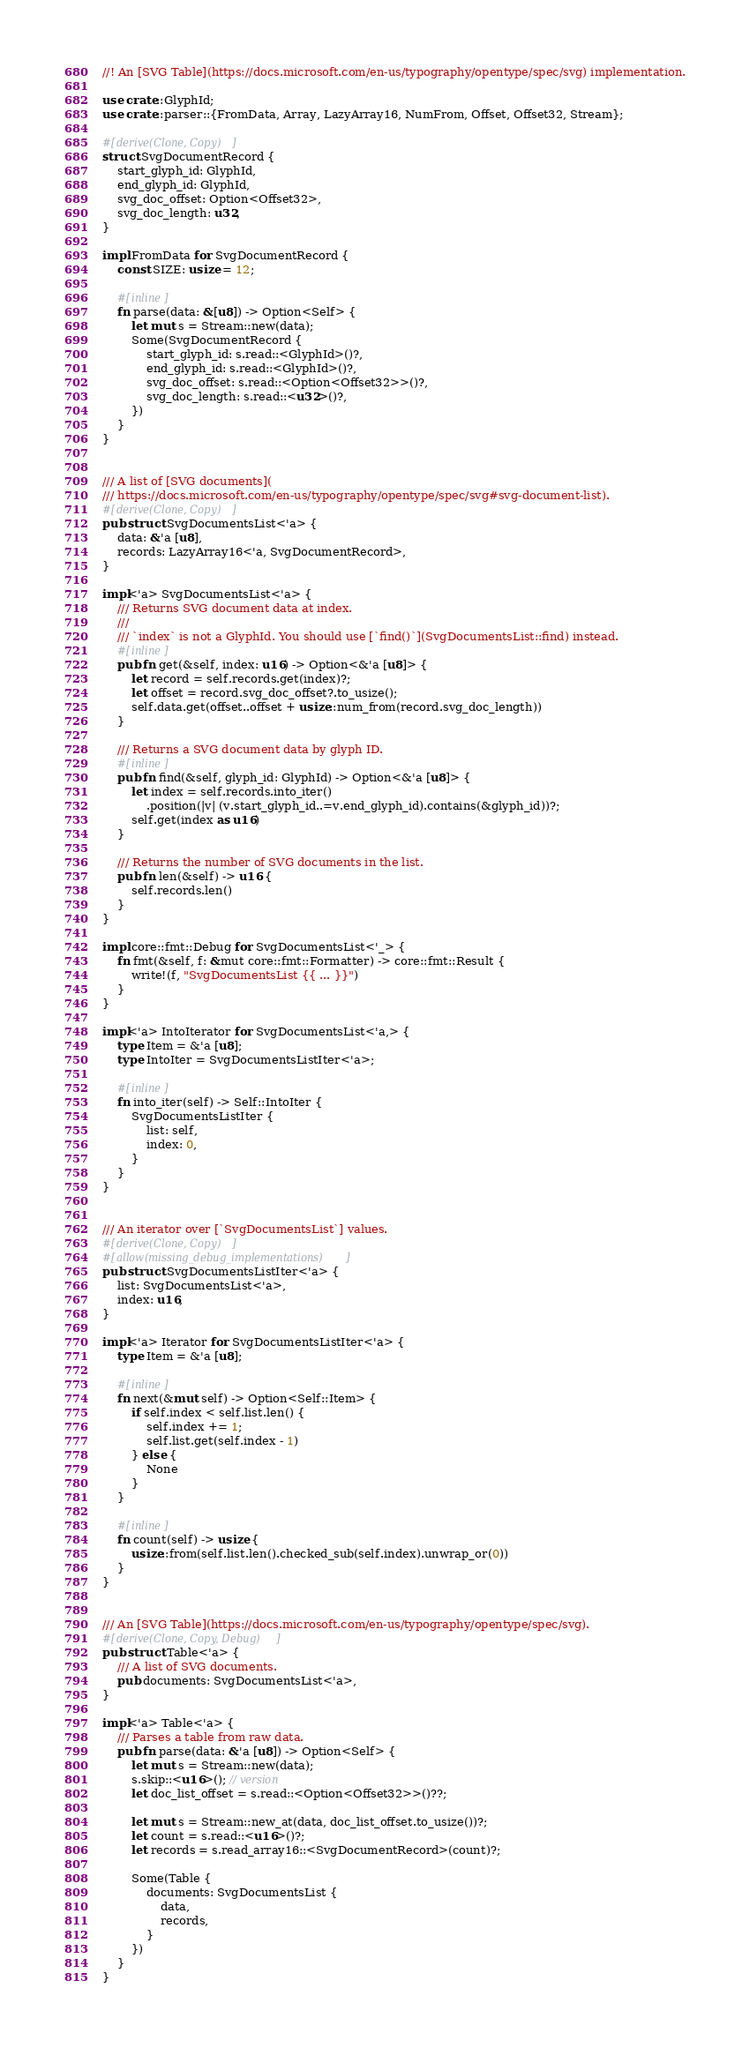Convert code to text. <code><loc_0><loc_0><loc_500><loc_500><_Rust_>//! An [SVG Table](https://docs.microsoft.com/en-us/typography/opentype/spec/svg) implementation.

use crate::GlyphId;
use crate::parser::{FromData, Array, LazyArray16, NumFrom, Offset, Offset32, Stream};

#[derive(Clone, Copy)]
struct SvgDocumentRecord {
    start_glyph_id: GlyphId,
    end_glyph_id: GlyphId,
    svg_doc_offset: Option<Offset32>,
    svg_doc_length: u32,
}

impl FromData for SvgDocumentRecord {
    const SIZE: usize = 12;

    #[inline]
    fn parse(data: &[u8]) -> Option<Self> {
        let mut s = Stream::new(data);
        Some(SvgDocumentRecord {
            start_glyph_id: s.read::<GlyphId>()?,
            end_glyph_id: s.read::<GlyphId>()?,
            svg_doc_offset: s.read::<Option<Offset32>>()?,
            svg_doc_length: s.read::<u32>()?,
        })
    }
}


/// A list of [SVG documents](
/// https://docs.microsoft.com/en-us/typography/opentype/spec/svg#svg-document-list).
#[derive(Clone, Copy)]
pub struct SvgDocumentsList<'a> {
    data: &'a [u8],
    records: LazyArray16<'a, SvgDocumentRecord>,
}

impl<'a> SvgDocumentsList<'a> {
    /// Returns SVG document data at index.
    ///
    /// `index` is not a GlyphId. You should use [`find()`](SvgDocumentsList::find) instead.
    #[inline]
    pub fn get(&self, index: u16) -> Option<&'a [u8]> {
        let record = self.records.get(index)?;
        let offset = record.svg_doc_offset?.to_usize();
        self.data.get(offset..offset + usize::num_from(record.svg_doc_length))
    }

    /// Returns a SVG document data by glyph ID.
    #[inline]
    pub fn find(&self, glyph_id: GlyphId) -> Option<&'a [u8]> {
        let index = self.records.into_iter()
            .position(|v| (v.start_glyph_id..=v.end_glyph_id).contains(&glyph_id))?;
        self.get(index as u16)
    }

    /// Returns the number of SVG documents in the list.
    pub fn len(&self) -> u16 {
        self.records.len()
    }
}

impl core::fmt::Debug for SvgDocumentsList<'_> {
    fn fmt(&self, f: &mut core::fmt::Formatter) -> core::fmt::Result {
        write!(f, "SvgDocumentsList {{ ... }}")
    }
}

impl<'a> IntoIterator for SvgDocumentsList<'a,> {
    type Item = &'a [u8];
    type IntoIter = SvgDocumentsListIter<'a>;

    #[inline]
    fn into_iter(self) -> Self::IntoIter {
        SvgDocumentsListIter {
            list: self,
            index: 0,
        }
    }
}


/// An iterator over [`SvgDocumentsList`] values.
#[derive(Clone, Copy)]
#[allow(missing_debug_implementations)]
pub struct SvgDocumentsListIter<'a> {
    list: SvgDocumentsList<'a>,
    index: u16,
}

impl<'a> Iterator for SvgDocumentsListIter<'a> {
    type Item = &'a [u8];

    #[inline]
    fn next(&mut self) -> Option<Self::Item> {
        if self.index < self.list.len() {
            self.index += 1;
            self.list.get(self.index - 1)
        } else {
            None
        }
    }

    #[inline]
    fn count(self) -> usize {
        usize::from(self.list.len().checked_sub(self.index).unwrap_or(0))
    }
}


/// An [SVG Table](https://docs.microsoft.com/en-us/typography/opentype/spec/svg).
#[derive(Clone, Copy, Debug)]
pub struct Table<'a> {
    /// A list of SVG documents.
    pub documents: SvgDocumentsList<'a>,
}

impl<'a> Table<'a> {
    /// Parses a table from raw data.
    pub fn parse(data: &'a [u8]) -> Option<Self> {
        let mut s = Stream::new(data);
        s.skip::<u16>(); // version
        let doc_list_offset = s.read::<Option<Offset32>>()??;

        let mut s = Stream::new_at(data, doc_list_offset.to_usize())?;
        let count = s.read::<u16>()?;
        let records = s.read_array16::<SvgDocumentRecord>(count)?;

        Some(Table {
            documents: SvgDocumentsList {
                data,
                records,
            }
        })
    }
}
</code> 